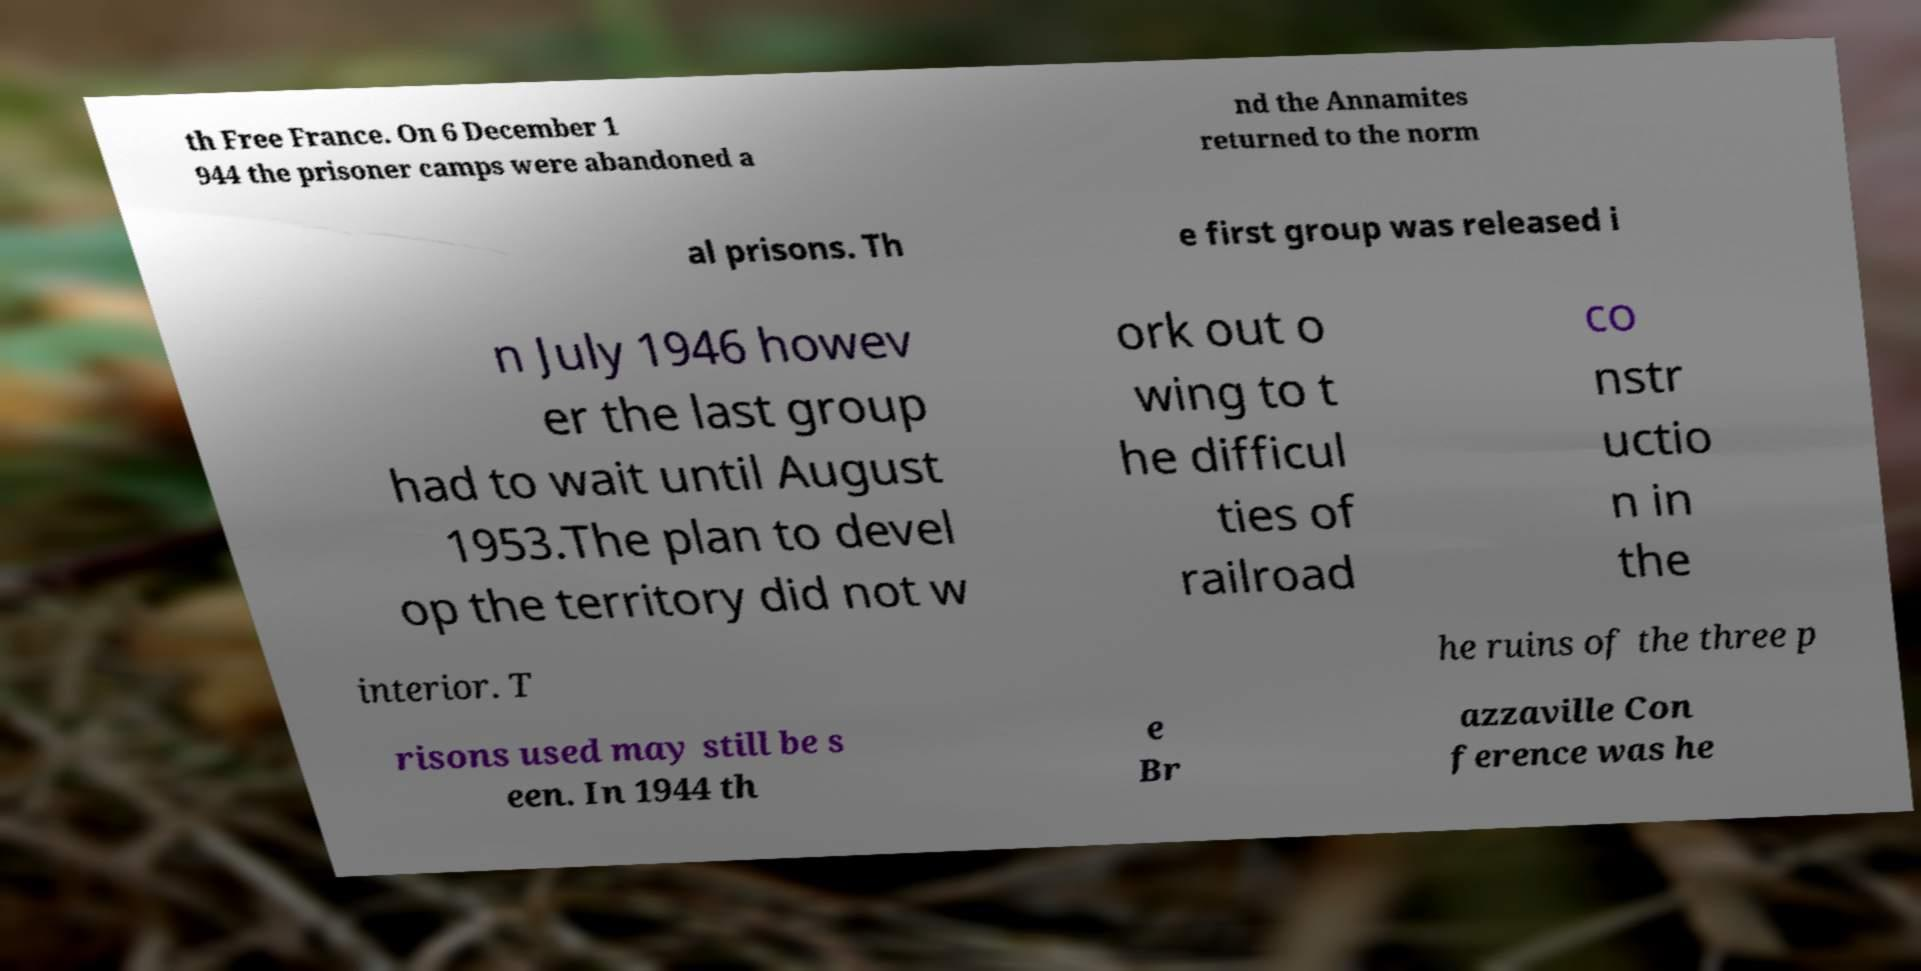Please read and relay the text visible in this image. What does it say? th Free France. On 6 December 1 944 the prisoner camps were abandoned a nd the Annamites returned to the norm al prisons. Th e first group was released i n July 1946 howev er the last group had to wait until August 1953.The plan to devel op the territory did not w ork out o wing to t he difficul ties of railroad co nstr uctio n in the interior. T he ruins of the three p risons used may still be s een. In 1944 th e Br azzaville Con ference was he 